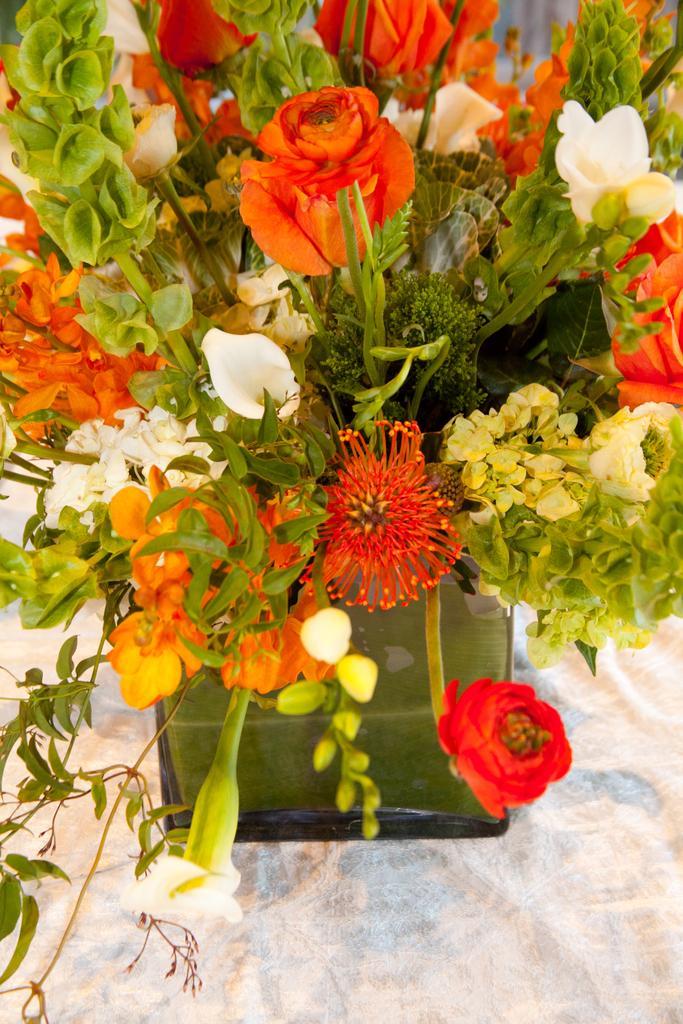How would you summarize this image in a sentence or two? In this image there is a white cloth, on that white cloth there is a flower bouquet. 